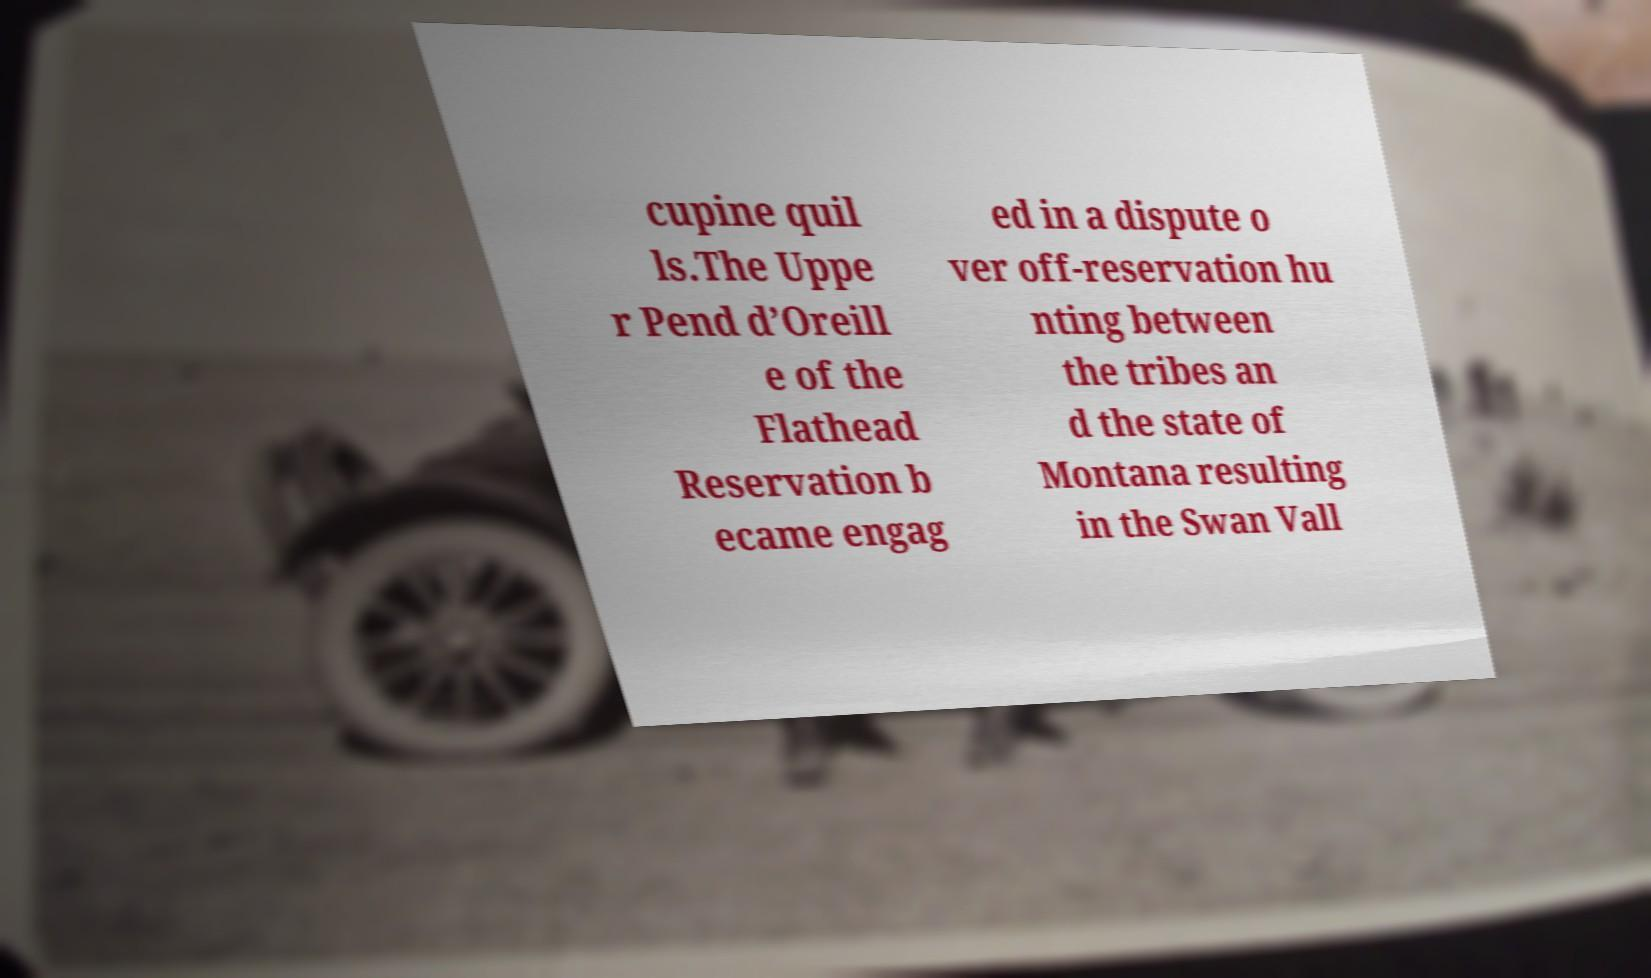Please read and relay the text visible in this image. What does it say? cupine quil ls.The Uppe r Pend d’Oreill e of the Flathead Reservation b ecame engag ed in a dispute o ver off-reservation hu nting between the tribes an d the state of Montana resulting in the Swan Vall 